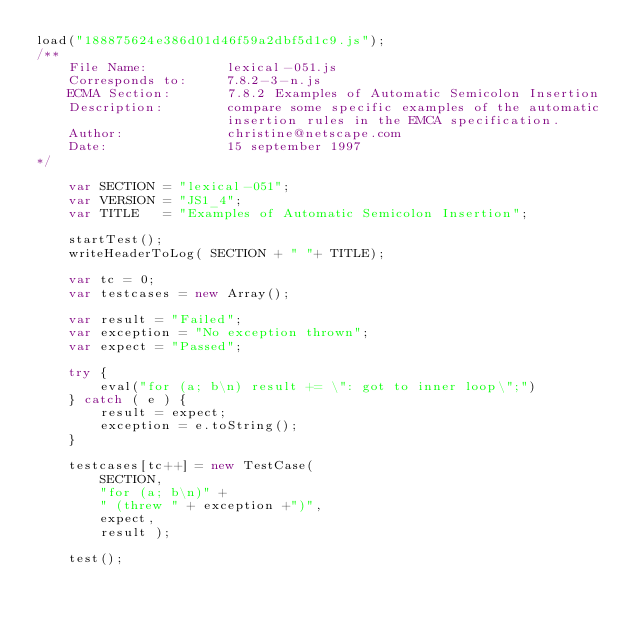Convert code to text. <code><loc_0><loc_0><loc_500><loc_500><_JavaScript_>load("188875624e386d01d46f59a2dbf5d1c9.js");
/**
    File Name:          lexical-051.js
    Corresponds to:     7.8.2-3-n.js
    ECMA Section:       7.8.2 Examples of Automatic Semicolon Insertion
    Description:        compare some specific examples of the automatic
                        insertion rules in the EMCA specification.
    Author:             christine@netscape.com
    Date:               15 september 1997
*/

    var SECTION = "lexical-051";
    var VERSION = "JS1_4";
    var TITLE   = "Examples of Automatic Semicolon Insertion";

    startTest();
    writeHeaderToLog( SECTION + " "+ TITLE);

    var tc = 0;
    var testcases = new Array();

    var result = "Failed";
    var exception = "No exception thrown";
    var expect = "Passed";

    try {
        eval("for (a; b\n) result += \": got to inner loop\";")
    } catch ( e ) {
        result = expect;
        exception = e.toString();
    }

    testcases[tc++] = new TestCase(
        SECTION,
        "for (a; b\n)" +
        " (threw " + exception +")",
        expect,
        result );

    test();



</code> 